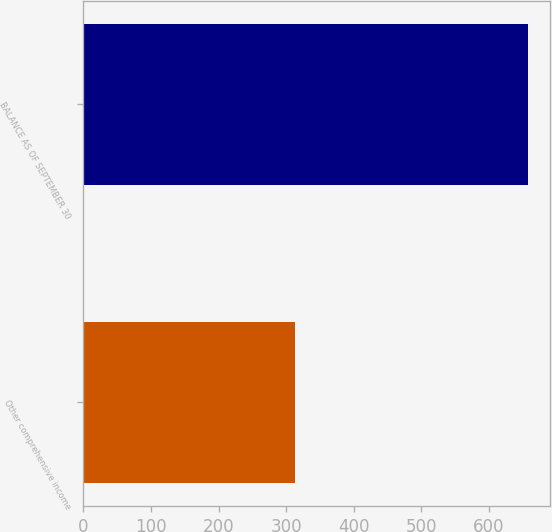Convert chart. <chart><loc_0><loc_0><loc_500><loc_500><bar_chart><fcel>Other comprehensive income<fcel>BALANCE AS OF SEPTEMBER 30<nl><fcel>312.8<fcel>658.1<nl></chart> 